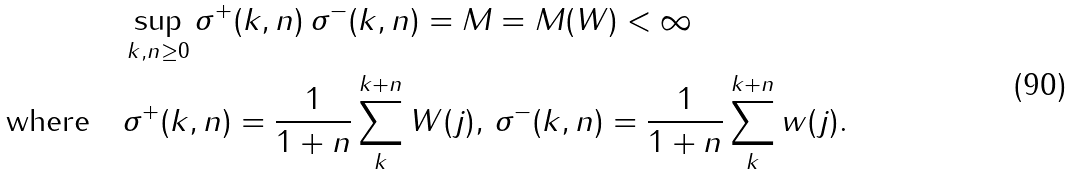<formula> <loc_0><loc_0><loc_500><loc_500>& \sup _ { k , n \geq 0 } \sigma ^ { + } ( k , n ) \, \sigma ^ { - } ( k , n ) = M = M ( W ) < \infty \\ \text {where} \quad & \sigma ^ { + } ( k , n ) = \frac { 1 } { 1 + n } \sum _ { k } ^ { k + n } W ( j ) , \, \sigma ^ { - } ( k , n ) = \frac { 1 } { 1 + n } \sum _ { k } ^ { k + n } w ( j ) .</formula> 